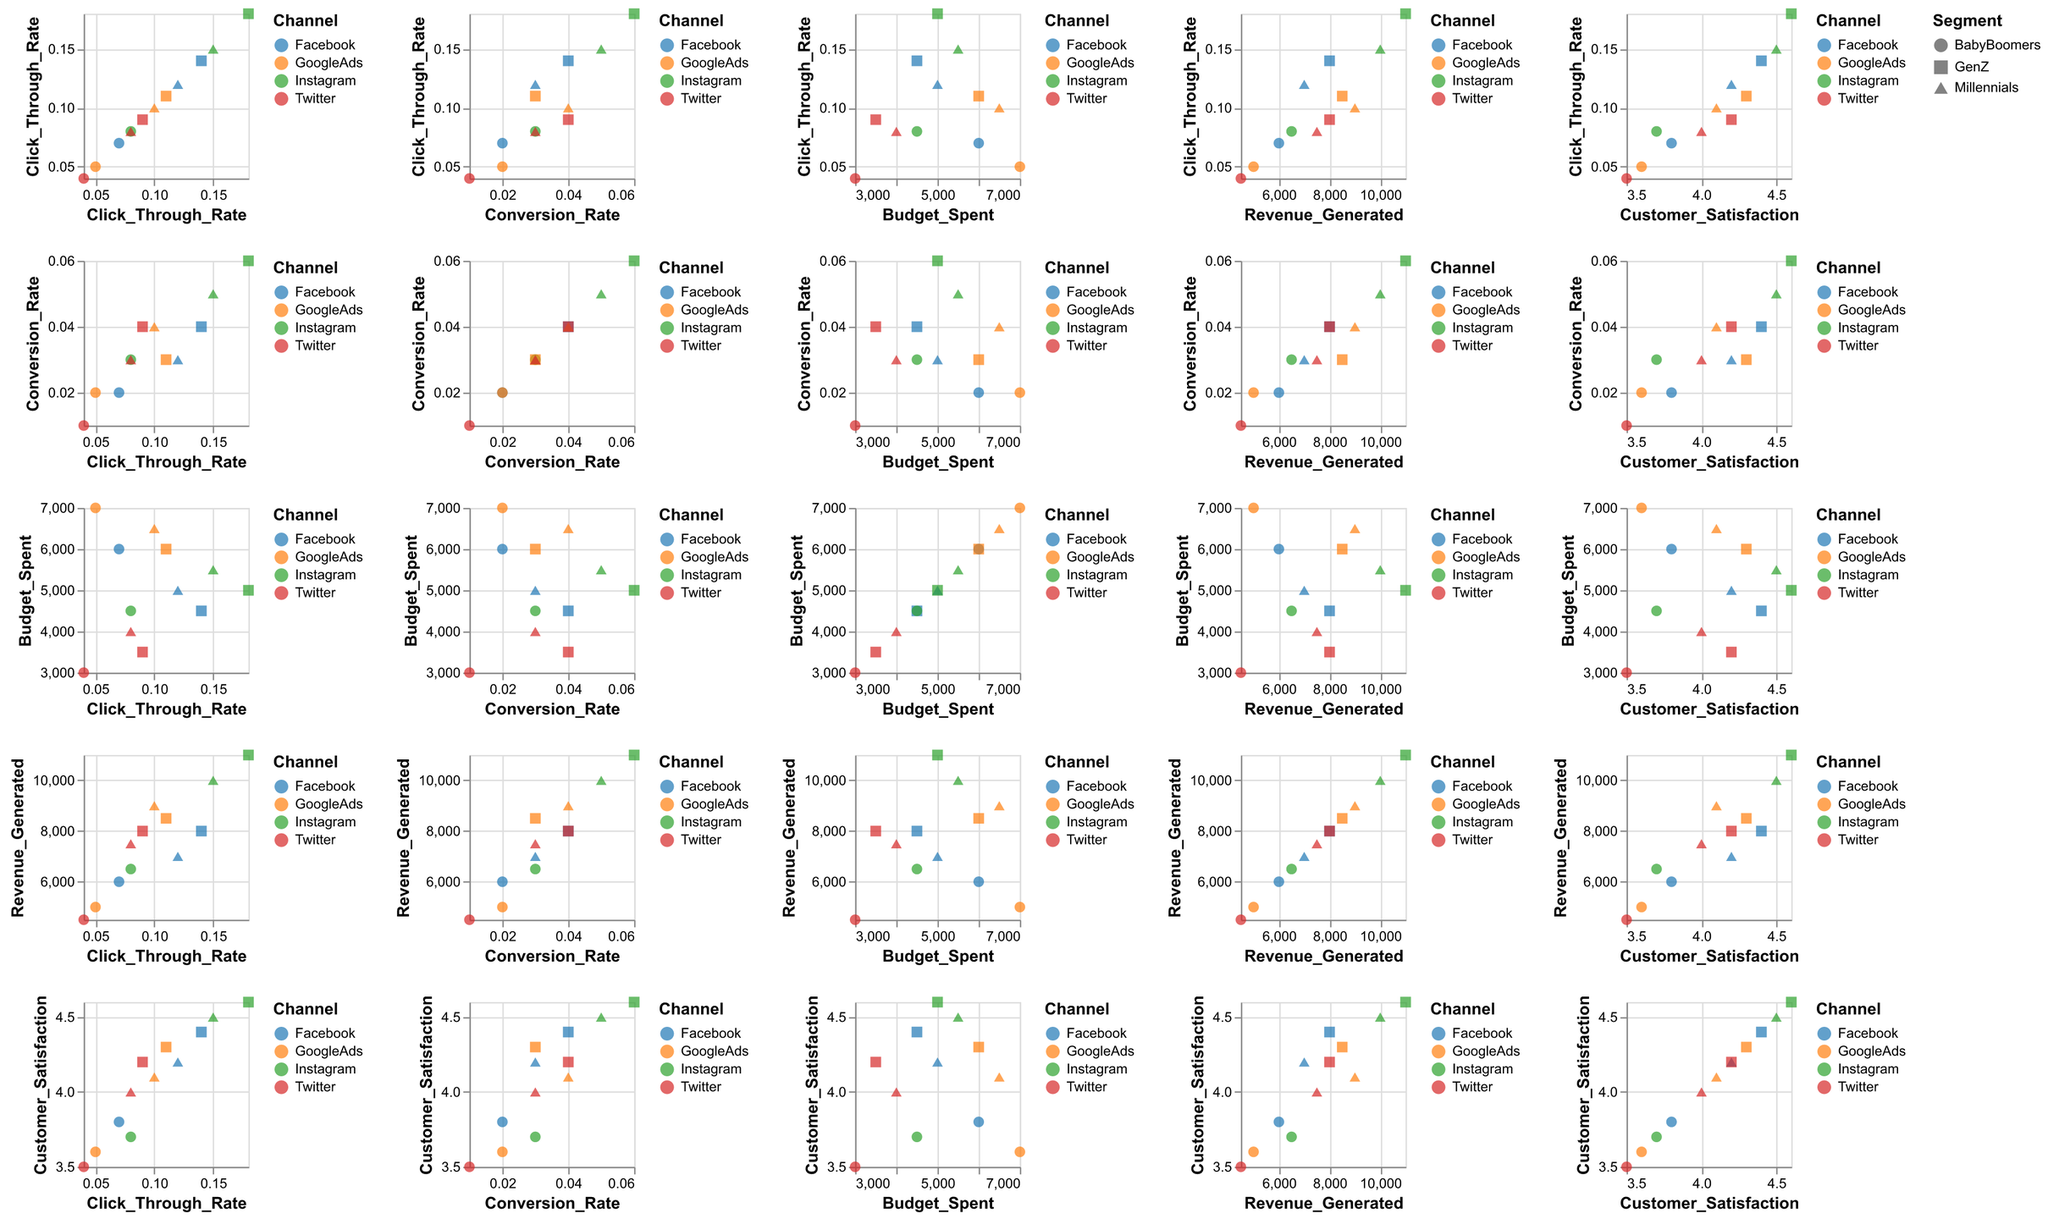How many different channels are represented in the plot? Count the unique values in the "Channel" field based on the colors depicted in the plot.
Answer: 4 Which channel has the highest average Click Through Rate (CTR) across all segments? Calculate the average CTR for each channel by summing the CTR values for each segment and dividing by the number of segments. Facebook: (0.12 + 0.14 + 0.07) / 3, Instagram: (0.15 + 0.18 + 0.08) / 3, GoogleAds: (0.10 + 0.11 + 0.05) / 3, Twitter: (0.08 + 0.09 + 0.04) / 3. Instagram has the highest average.
Answer: Instagram Which segment has the lowest Conversion Rate (CR) on Twitter? Compare the CR values for each segment under Twitter by referring to the shape and the position along the "Conversion Rate" axis. BabyBoomers segment has the lowest CR of 0.01.
Answer: BabyBoomers Is there a segment with consistently higher Customer Satisfaction across all channels? Compare the Customer Satisfaction values for each segment across all channels by referring to the shape and position of points. GenZ consistently has higher Customer Satisfaction values.
Answer: GenZ Which channel and segment combination generates the highest revenue? Identify the highest "Revenue_Generated" value by comparing all data points in the "Revenue_Generated" axis. Instagram and GenZ with 11000 in revenue.
Answer: Instagram, GenZ What is the relationship between Budget Spent and Revenue Generated for Instagram? Look at the scatter plots of Budget Spent vs. Revenue Generated for Instagram by noting the color representation. Higher Budget Spent tends to lead to higher Revenue Generated.
Answer: Positive correlation Do Baby Boomers have a higher Click Through Rate (CTR) on Facebook or Google Ads? Compare the points for Baby Boomers in "Click_Through_Rate" for Facebook and GoogleAds. Facebook: 0.07, GoogleAds: 0.05. Facebook has a higher CTR for Baby Boomers.
Answer: Facebook Which channel has the least budget spent on any segment? Identify the minimum value on the "Budget_Spent" axis by checking all points. Twitter has the minimum budget spent at 3000 for Baby Boomers.
Answer: Twitter What's the total revenue generated by Millennials across all channels? Sum the "Revenue_Generated" values for Millennials for each channel: (7000 + 10000 + 9000 + 7500). The total is 33500.
Answer: 33500 